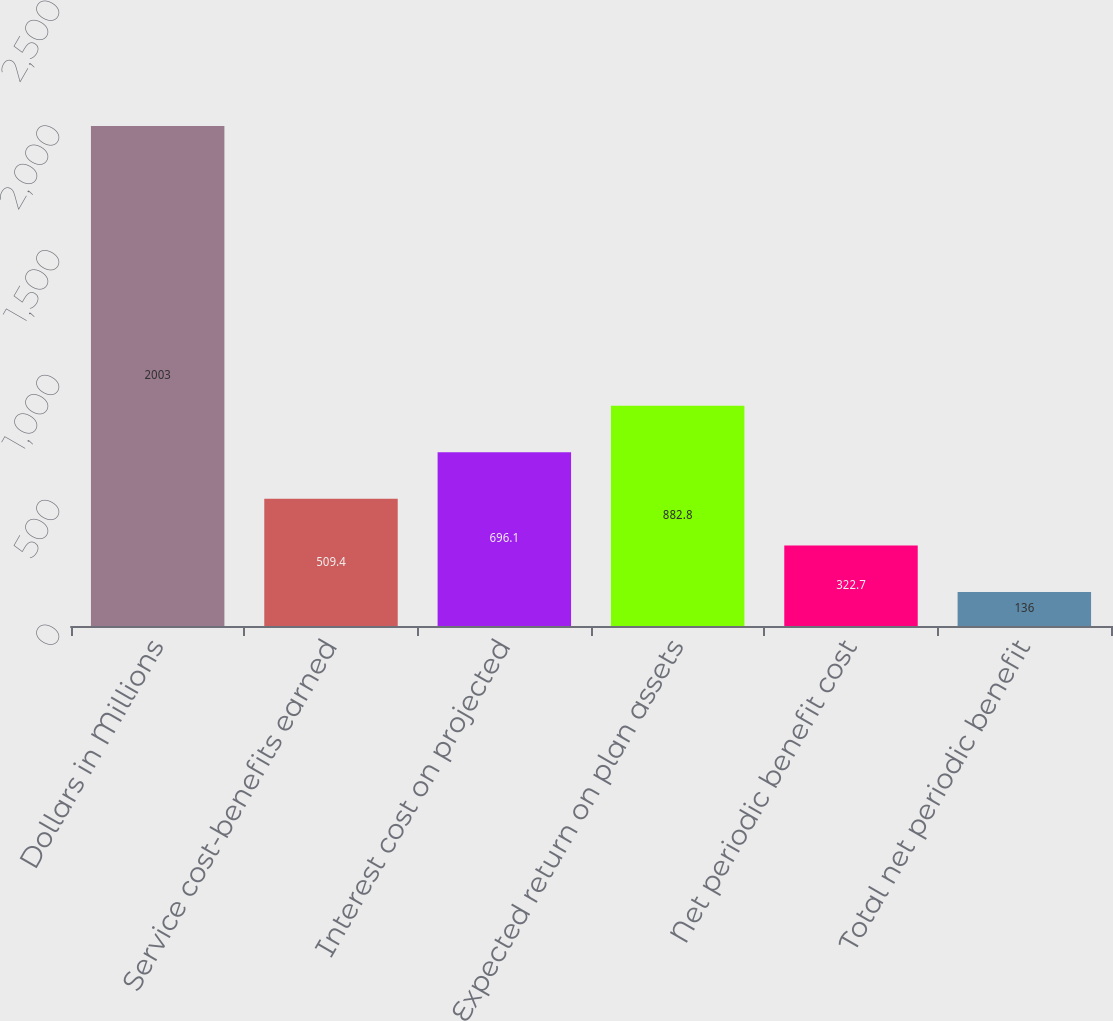<chart> <loc_0><loc_0><loc_500><loc_500><bar_chart><fcel>Dollars in Millions<fcel>Service cost-benefits earned<fcel>Interest cost on projected<fcel>Expected return on plan assets<fcel>Net periodic benefit cost<fcel>Total net periodic benefit<nl><fcel>2003<fcel>509.4<fcel>696.1<fcel>882.8<fcel>322.7<fcel>136<nl></chart> 